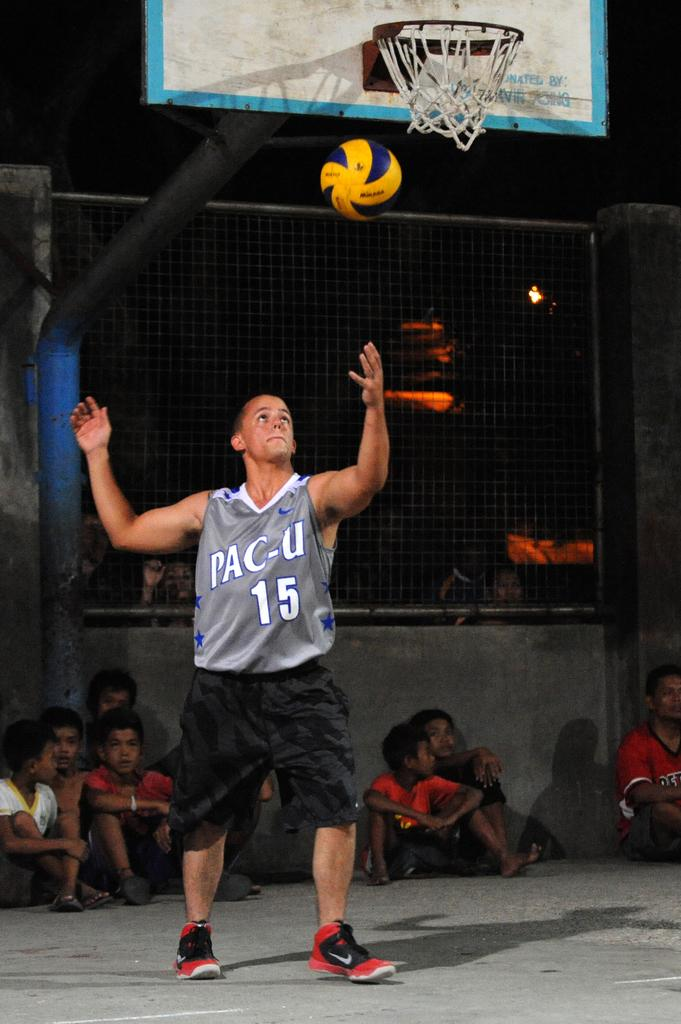<image>
Share a concise interpretation of the image provided. a basketball player with the number 15 on it that says pac-u 